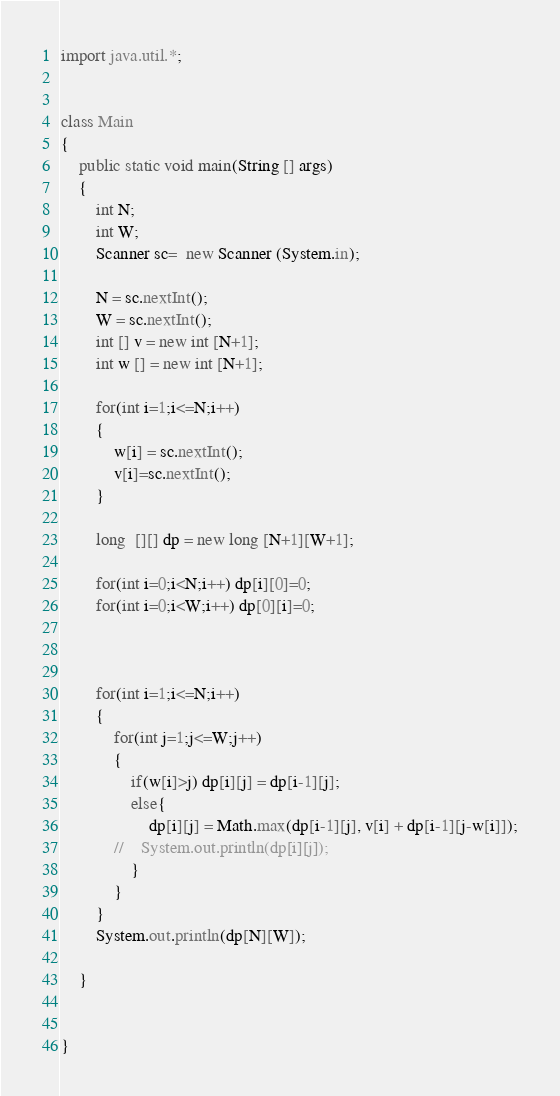<code> <loc_0><loc_0><loc_500><loc_500><_Java_>import java.util.*;


class Main
{
    public static void main(String [] args)
    {
        int N; 
        int W;
        Scanner sc=  new Scanner (System.in);

        N = sc.nextInt();
        W = sc.nextInt();
        int [] v = new int [N+1];
        int w [] = new int [N+1];

        for(int i=1;i<=N;i++)
        {
            w[i] = sc.nextInt();
            v[i]=sc.nextInt();
        }

        long  [][] dp = new long [N+1][W+1];

        for(int i=0;i<N;i++) dp[i][0]=0;
        for(int i=0;i<W;i++) dp[0][i]=0;



        for(int i=1;i<=N;i++)
        {
            for(int j=1;j<=W;j++)
            {
                if(w[i]>j) dp[i][j] = dp[i-1][j];
                else{
                    dp[i][j] = Math.max(dp[i-1][j], v[i] + dp[i-1][j-w[i]]);
            //    System.out.println(dp[i][j]);
                }
            }
        }
        System.out.println(dp[N][W]);
        
    }


}
</code> 